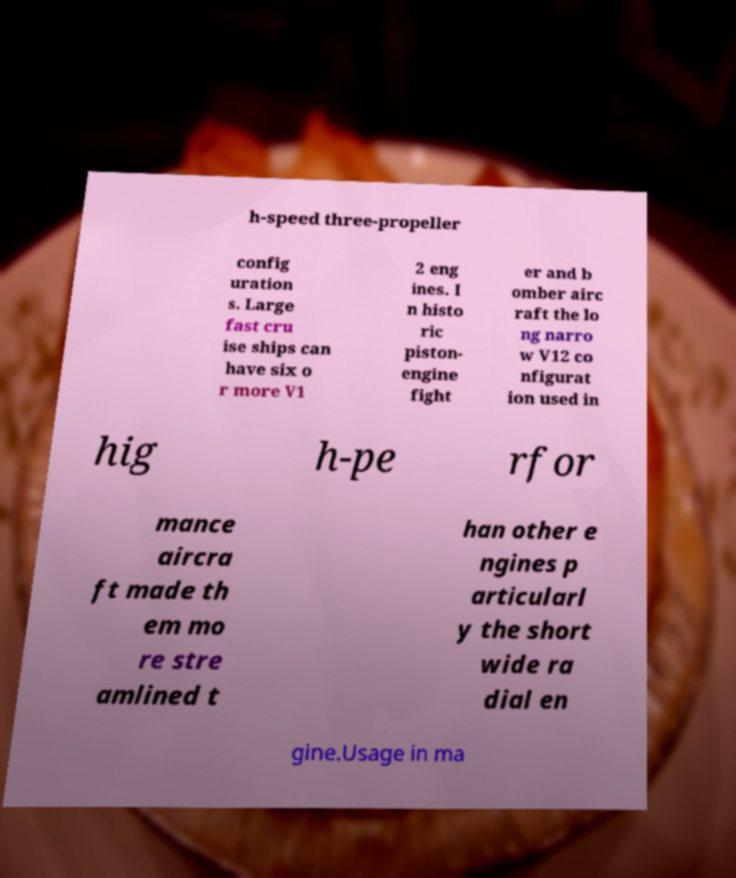Please identify and transcribe the text found in this image. h-speed three-propeller config uration s. Large fast cru ise ships can have six o r more V1 2 eng ines. I n histo ric piston- engine fight er and b omber airc raft the lo ng narro w V12 co nfigurat ion used in hig h-pe rfor mance aircra ft made th em mo re stre amlined t han other e ngines p articularl y the short wide ra dial en gine.Usage in ma 